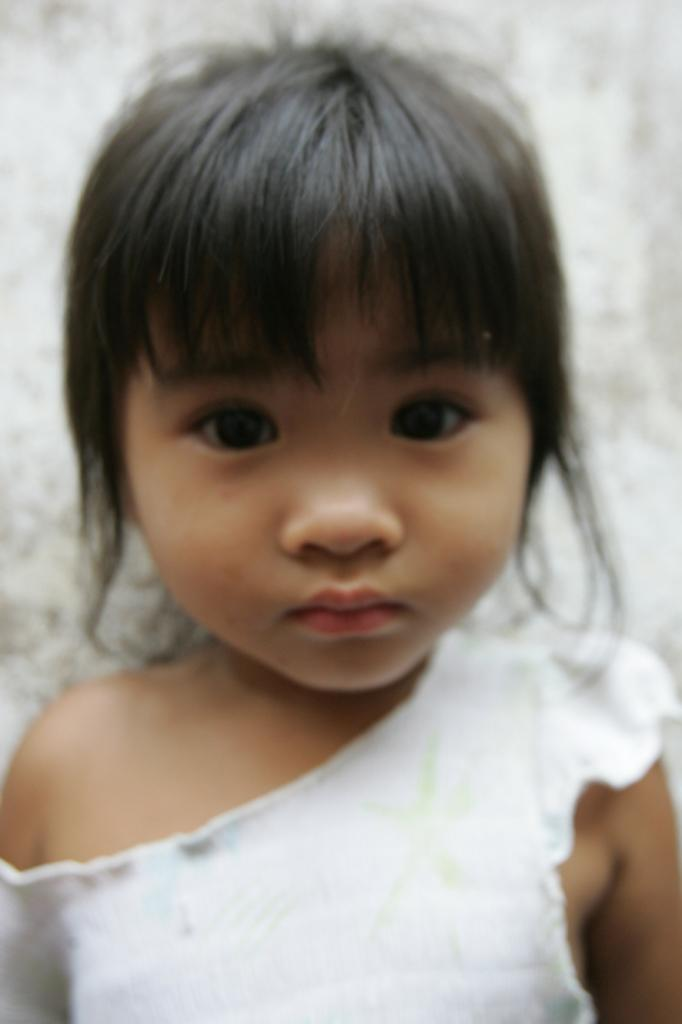Who is the main subject in the image? There is a girl in the image. What color is the background of the image? The background of the image is white. Can you see any veins in the girl's hands in the image? There is no information about the girl's hands or veins in the image, so it cannot be determined from the image. 